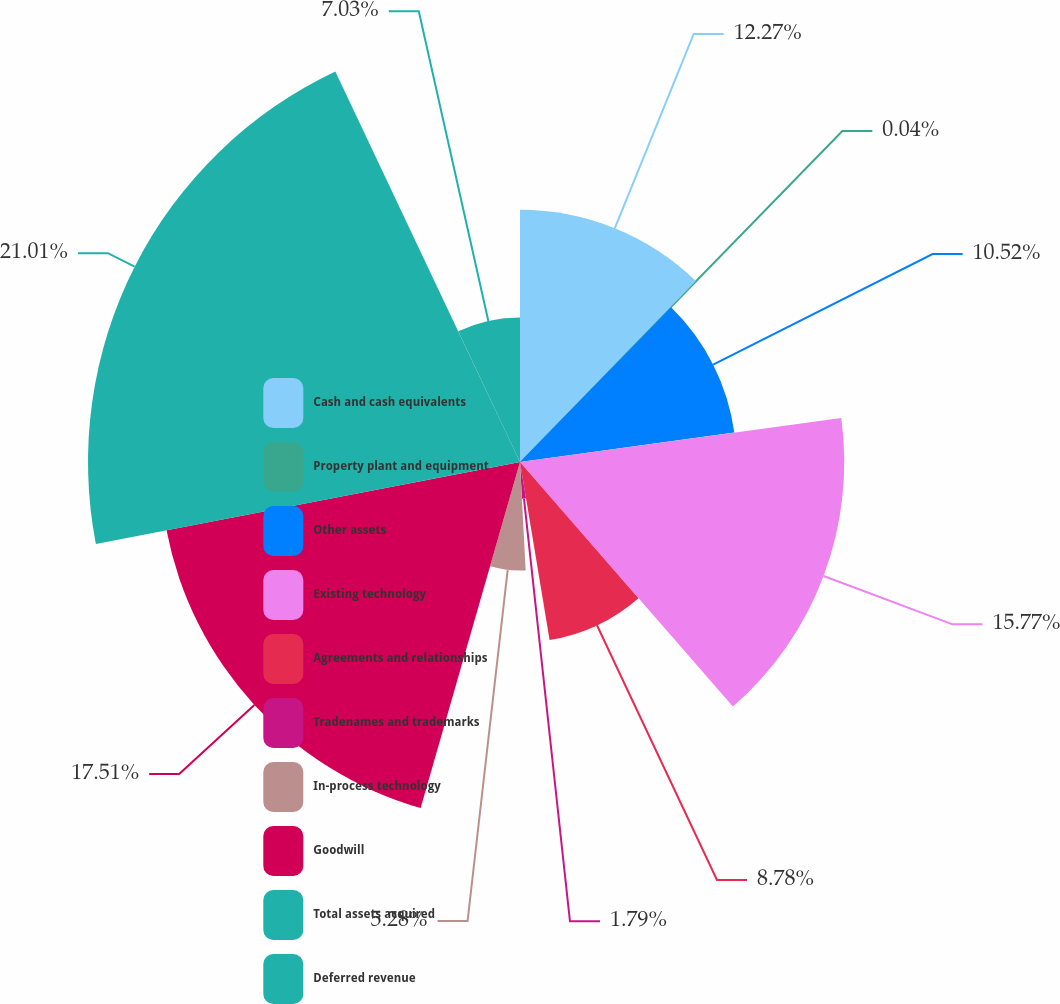Convert chart to OTSL. <chart><loc_0><loc_0><loc_500><loc_500><pie_chart><fcel>Cash and cash equivalents<fcel>Property plant and equipment<fcel>Other assets<fcel>Existing technology<fcel>Agreements and relationships<fcel>Tradenames and trademarks<fcel>In-process technology<fcel>Goodwill<fcel>Total assets acquired<fcel>Deferred revenue<nl><fcel>12.27%<fcel>0.04%<fcel>10.52%<fcel>15.77%<fcel>8.78%<fcel>1.79%<fcel>5.28%<fcel>17.51%<fcel>21.01%<fcel>7.03%<nl></chart> 